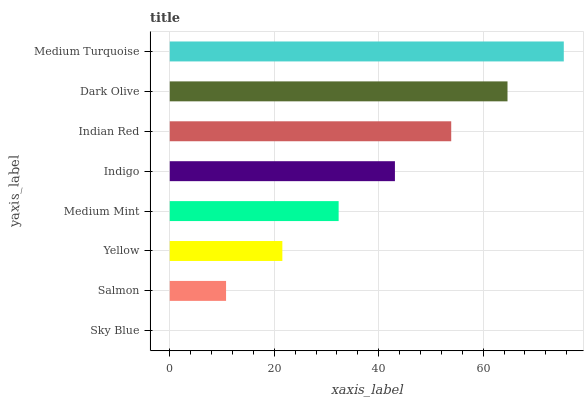Is Sky Blue the minimum?
Answer yes or no. Yes. Is Medium Turquoise the maximum?
Answer yes or no. Yes. Is Salmon the minimum?
Answer yes or no. No. Is Salmon the maximum?
Answer yes or no. No. Is Salmon greater than Sky Blue?
Answer yes or no. Yes. Is Sky Blue less than Salmon?
Answer yes or no. Yes. Is Sky Blue greater than Salmon?
Answer yes or no. No. Is Salmon less than Sky Blue?
Answer yes or no. No. Is Indigo the high median?
Answer yes or no. Yes. Is Medium Mint the low median?
Answer yes or no. Yes. Is Medium Turquoise the high median?
Answer yes or no. No. Is Yellow the low median?
Answer yes or no. No. 